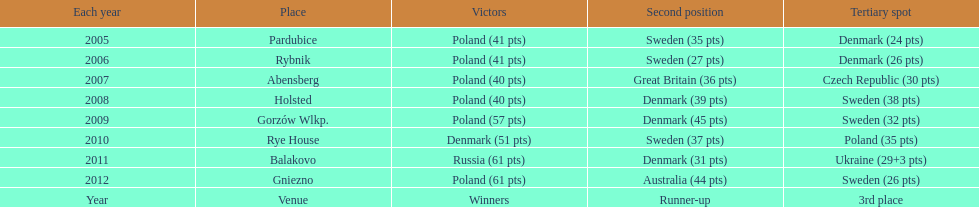What was the last year 3rd place finished with less than 25 points? 2005. 